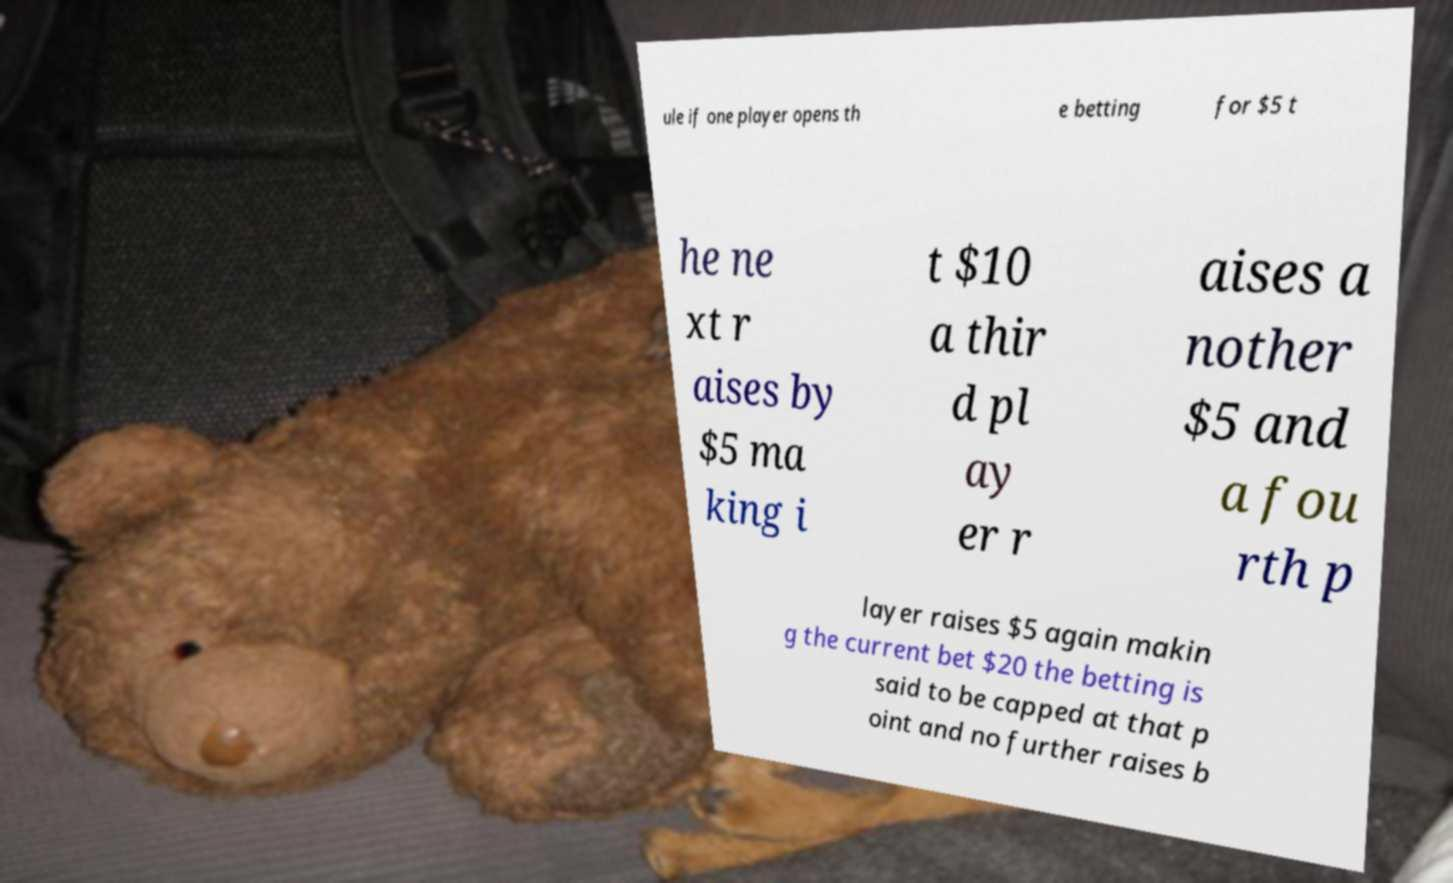Please read and relay the text visible in this image. What does it say? ule if one player opens th e betting for $5 t he ne xt r aises by $5 ma king i t $10 a thir d pl ay er r aises a nother $5 and a fou rth p layer raises $5 again makin g the current bet $20 the betting is said to be capped at that p oint and no further raises b 